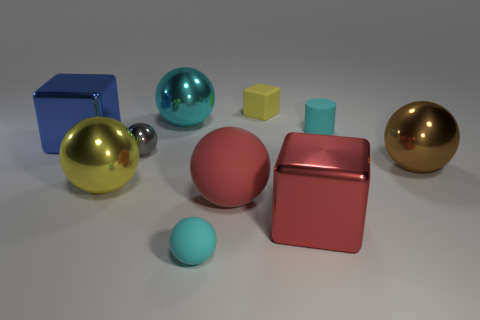Subtract all large cubes. How many cubes are left? 1 Subtract all spheres. How many objects are left? 4 Subtract all yellow balls. Subtract all cyan cubes. How many balls are left? 5 Subtract all red cubes. How many cyan balls are left? 2 Subtract all small cyan matte blocks. Subtract all tiny cyan matte cylinders. How many objects are left? 9 Add 2 red matte spheres. How many red matte spheres are left? 3 Add 4 large blue spheres. How many large blue spheres exist? 4 Subtract all yellow cubes. How many cubes are left? 2 Subtract 1 yellow spheres. How many objects are left? 9 Subtract 6 balls. How many balls are left? 0 